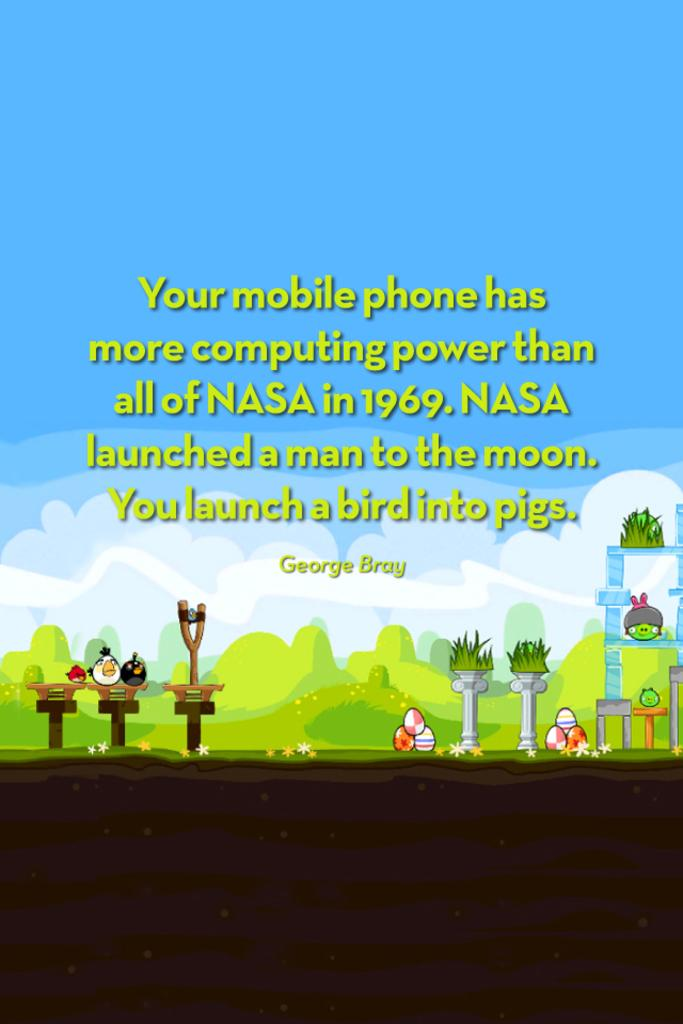Provide a one-sentence caption for the provided image. A poster with a quote from George Bray that explains the computing power of your phone is depicted. 